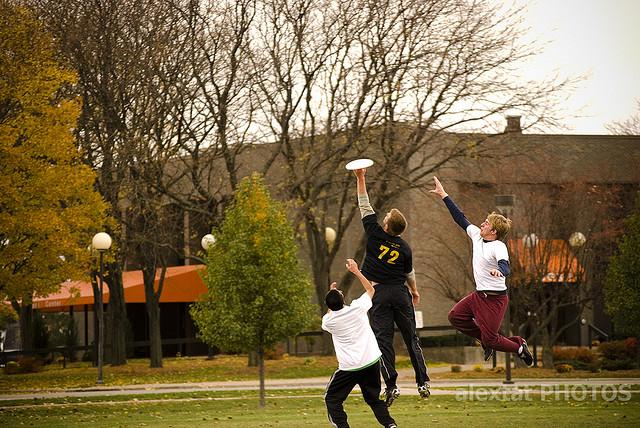What number is on the back of the middle person's shirt?
Keep it brief. 72. What color is the building?
Be succinct. Brown. Are these people playing in a park?
Concise answer only. Yes. Why are the men jumping?
Give a very brief answer. To catch frisbee. 